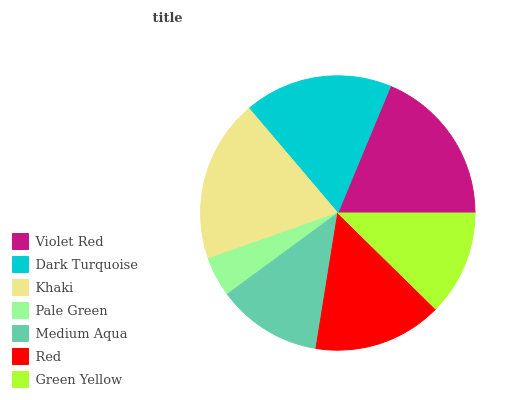Is Pale Green the minimum?
Answer yes or no. Yes. Is Khaki the maximum?
Answer yes or no. Yes. Is Dark Turquoise the minimum?
Answer yes or no. No. Is Dark Turquoise the maximum?
Answer yes or no. No. Is Violet Red greater than Dark Turquoise?
Answer yes or no. Yes. Is Dark Turquoise less than Violet Red?
Answer yes or no. Yes. Is Dark Turquoise greater than Violet Red?
Answer yes or no. No. Is Violet Red less than Dark Turquoise?
Answer yes or no. No. Is Red the high median?
Answer yes or no. Yes. Is Red the low median?
Answer yes or no. Yes. Is Medium Aqua the high median?
Answer yes or no. No. Is Medium Aqua the low median?
Answer yes or no. No. 